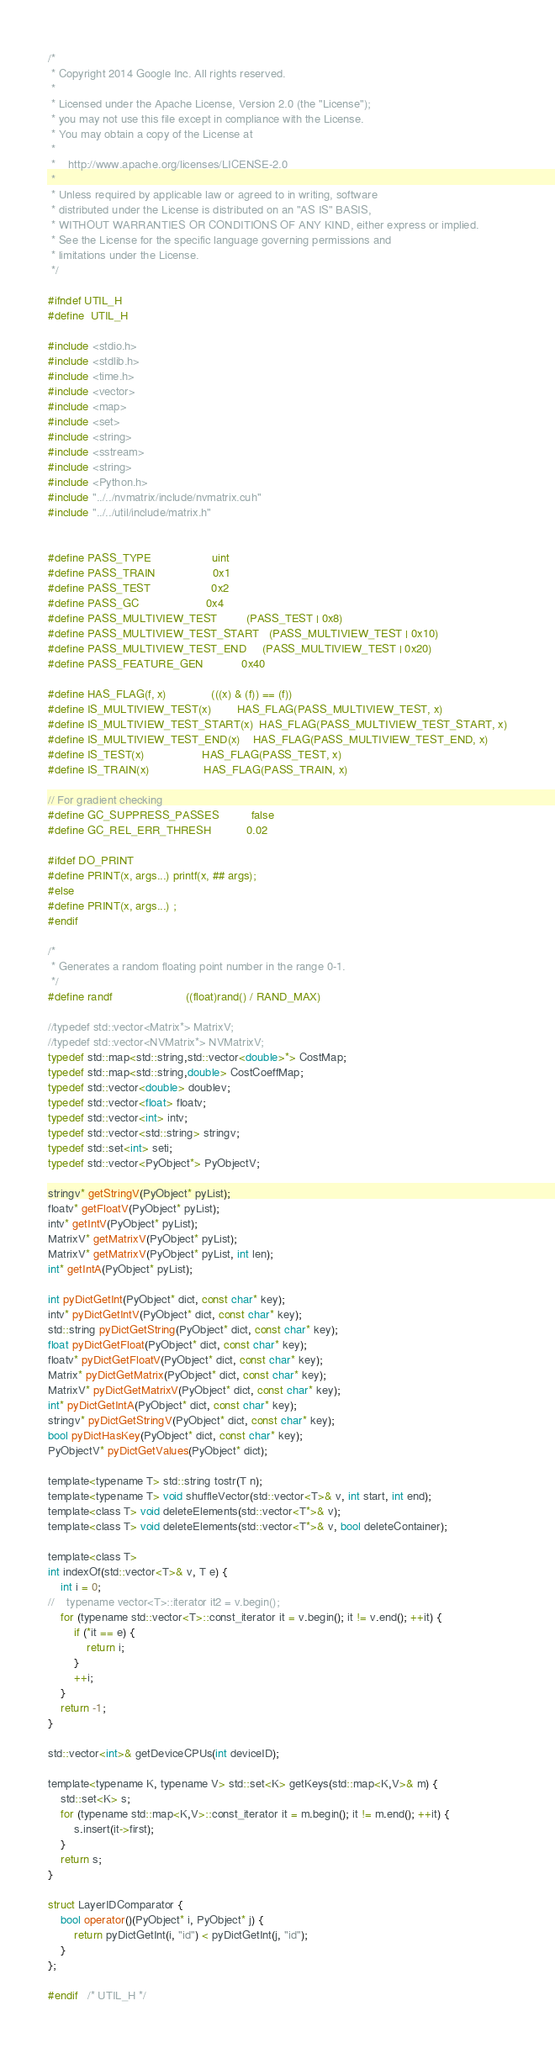Convert code to text. <code><loc_0><loc_0><loc_500><loc_500><_Cuda_>/*
 * Copyright 2014 Google Inc. All rights reserved.
 *
 * Licensed under the Apache License, Version 2.0 (the "License");
 * you may not use this file except in compliance with the License.
 * You may obtain a copy of the License at
 *
 *    http://www.apache.org/licenses/LICENSE-2.0
 *
 * Unless required by applicable law or agreed to in writing, software
 * distributed under the License is distributed on an "AS IS" BASIS,
 * WITHOUT WARRANTIES OR CONDITIONS OF ANY KIND, either express or implied.
 * See the License for the specific language governing permissions and
 * limitations under the License.
 */

#ifndef UTIL_H
#define	UTIL_H

#include <stdio.h>
#include <stdlib.h>
#include <time.h>
#include <vector>
#include <map>
#include <set>
#include <string>
#include <sstream>
#include <string>
#include <Python.h>
#include "../../nvmatrix/include/nvmatrix.cuh"
#include "../../util/include/matrix.h"


#define PASS_TYPE                   uint
#define PASS_TRAIN                  0x1
#define PASS_TEST                   0x2
#define PASS_GC                     0x4
#define PASS_MULTIVIEW_TEST         (PASS_TEST | 0x8)
#define PASS_MULTIVIEW_TEST_START   (PASS_MULTIVIEW_TEST | 0x10)
#define PASS_MULTIVIEW_TEST_END     (PASS_MULTIVIEW_TEST | 0x20)
#define PASS_FEATURE_GEN            0x40

#define HAS_FLAG(f, x)              (((x) & (f)) == (f))
#define IS_MULTIVIEW_TEST(x)        HAS_FLAG(PASS_MULTIVIEW_TEST, x)
#define IS_MULTIVIEW_TEST_START(x)  HAS_FLAG(PASS_MULTIVIEW_TEST_START, x)
#define IS_MULTIVIEW_TEST_END(x)    HAS_FLAG(PASS_MULTIVIEW_TEST_END, x)
#define IS_TEST(x)                  HAS_FLAG(PASS_TEST, x)
#define IS_TRAIN(x)                 HAS_FLAG(PASS_TRAIN, x)

// For gradient checking
#define GC_SUPPRESS_PASSES          false
#define GC_REL_ERR_THRESH           0.02

#ifdef DO_PRINT
#define PRINT(x, args...) printf(x, ## args);
#else
#define PRINT(x, args...) ;
#endif

/*
 * Generates a random floating point number in the range 0-1.
 */
#define randf                       ((float)rand() / RAND_MAX)

//typedef std::vector<Matrix*> MatrixV;
//typedef std::vector<NVMatrix*> NVMatrixV;
typedef std::map<std::string,std::vector<double>*> CostMap;
typedef std::map<std::string,double> CostCoeffMap;
typedef std::vector<double> doublev;
typedef std::vector<float> floatv;
typedef std::vector<int> intv;
typedef std::vector<std::string> stringv;
typedef std::set<int> seti;
typedef std::vector<PyObject*> PyObjectV;

stringv* getStringV(PyObject* pyList);
floatv* getFloatV(PyObject* pyList);
intv* getIntV(PyObject* pyList);
MatrixV* getMatrixV(PyObject* pyList);
MatrixV* getMatrixV(PyObject* pyList, int len);
int* getIntA(PyObject* pyList);

int pyDictGetInt(PyObject* dict, const char* key);
intv* pyDictGetIntV(PyObject* dict, const char* key);
std::string pyDictGetString(PyObject* dict, const char* key);
float pyDictGetFloat(PyObject* dict, const char* key);
floatv* pyDictGetFloatV(PyObject* dict, const char* key);
Matrix* pyDictGetMatrix(PyObject* dict, const char* key);
MatrixV* pyDictGetMatrixV(PyObject* dict, const char* key);
int* pyDictGetIntA(PyObject* dict, const char* key);
stringv* pyDictGetStringV(PyObject* dict, const char* key);
bool pyDictHasKey(PyObject* dict, const char* key);
PyObjectV* pyDictGetValues(PyObject* dict);

template<typename T> std::string tostr(T n);
template<typename T> void shuffleVector(std::vector<T>& v, int start, int end);
template<class T> void deleteElements(std::vector<T*>& v);
template<class T> void deleteElements(std::vector<T*>& v, bool deleteContainer);

template<class T>
int indexOf(std::vector<T>& v, T e) {
    int i = 0;
//    typename vector<T>::iterator it2 = v.begin();
    for (typename std::vector<T>::const_iterator it = v.begin(); it != v.end(); ++it) {
        if (*it == e) {
            return i;
        }
        ++i;
    }
    return -1;
}

std::vector<int>& getDeviceCPUs(int deviceID);

template<typename K, typename V> std::set<K> getKeys(std::map<K,V>& m) {
    std::set<K> s;
    for (typename std::map<K,V>::const_iterator it = m.begin(); it != m.end(); ++it) {
        s.insert(it->first);
    }
    return s;
}

struct LayerIDComparator {
    bool operator()(PyObject* i, PyObject* j) {
        return pyDictGetInt(i, "id") < pyDictGetInt(j, "id");
    }
};

#endif	/* UTIL_H */

</code> 